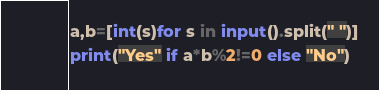<code> <loc_0><loc_0><loc_500><loc_500><_Python_>a,b=[int(s)for s in input().split(" ")]
print("Yes" if a*b%2!=0 else "No")</code> 